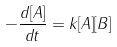<formula> <loc_0><loc_0><loc_500><loc_500>- \frac { d [ A ] } { d t } = k [ A ] [ B ]</formula> 